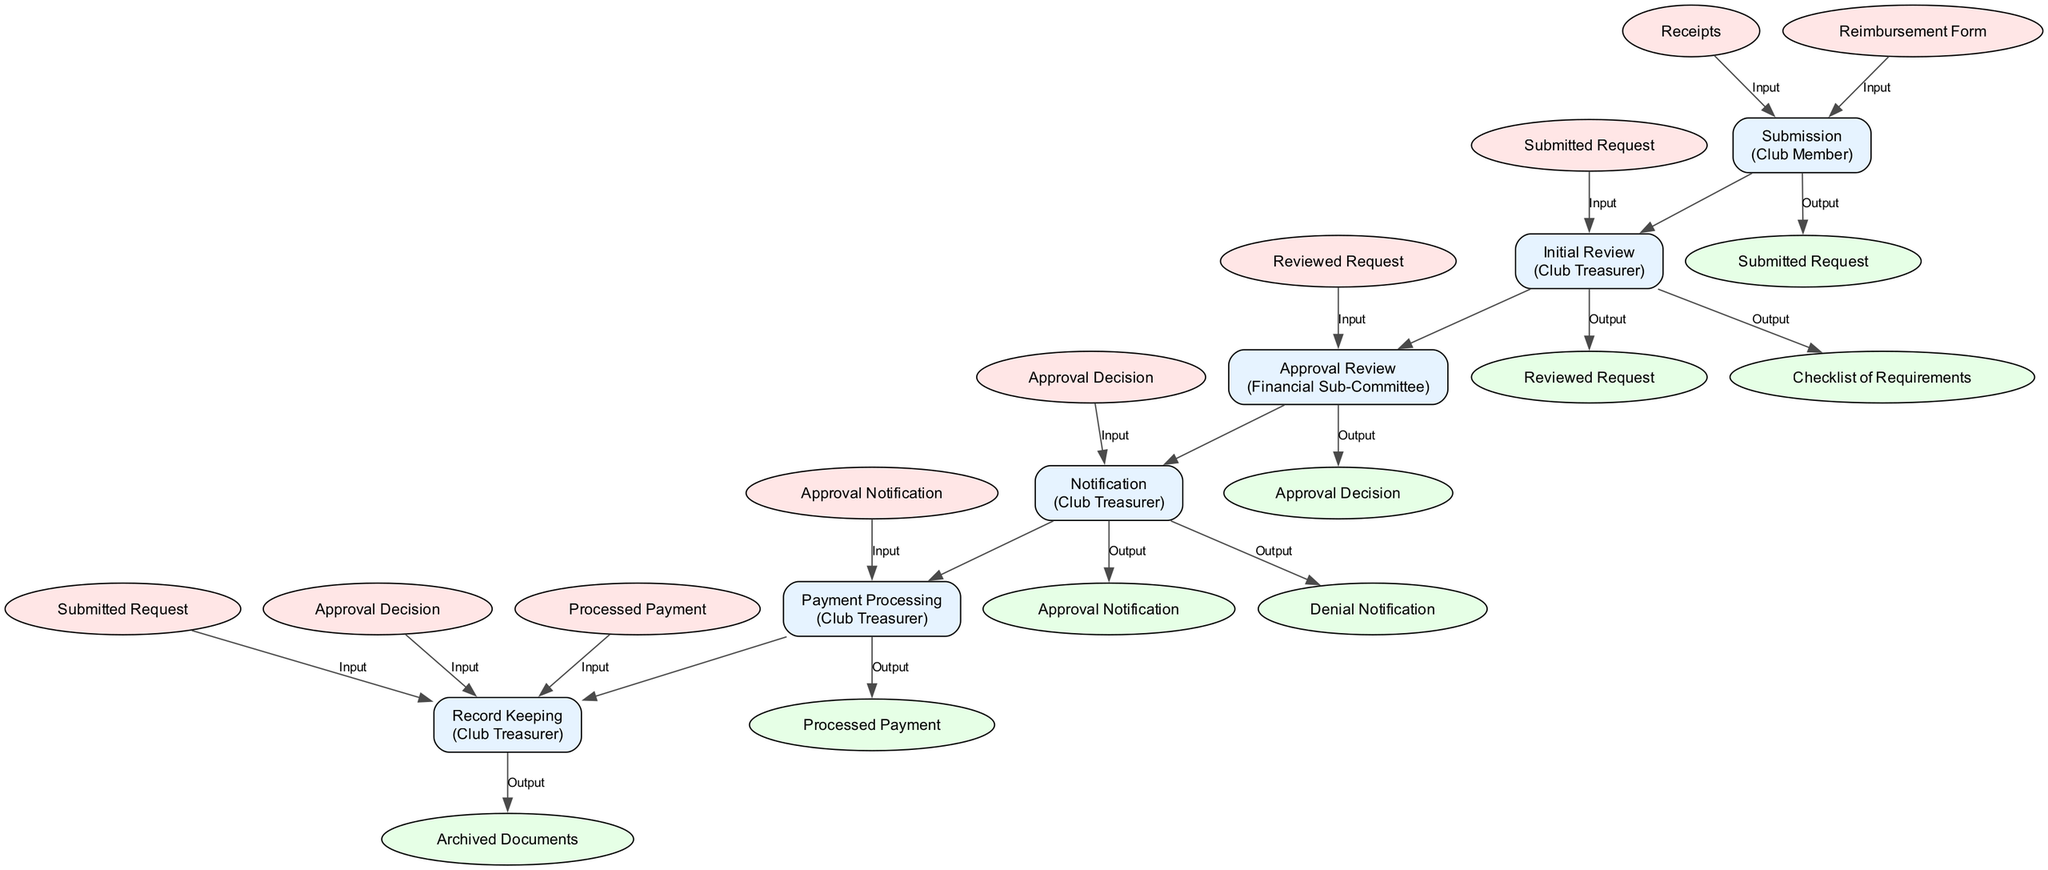What is the first step in the reimbursement procedure? The first step in the reimbursement procedure is "Submission" as indicated in the diagram.
Answer: Submission Who is responsible for the "Initial Review"? According to the diagram, the "Initial Review" is conducted by the "Club Treasurer".
Answer: Club Treasurer How many outputs does the "Approval Review" step generate? The "Approval Review" step generates one output, which is the "Approval Decision."
Answer: 1 What comes after the "Notification" step? After the "Notification" step, the next step is "Payment Processing". This is inferred by following the flow from "Notification" in the diagram.
Answer: Payment Processing What are the inputs required for the "Payment Processing" step? The input required for the "Payment Processing" step is the "Approval Notification". This is directly stated in the inputs section of the "Payment Processing" step in the diagram.
Answer: Approval Notification What is the final output in the reimbursement procedure? The final output of the reimbursement procedure is "Archived Documents" which comes from the last step "Record Keeping."
Answer: Archived Documents How many steps are in the reimbursement procedure? There are six steps in total, as counted from the nodes in the diagram that represent different steps in the process.
Answer: 6 What does the "Club Treasurer" do in the "Notification" step? In the "Notification" step, the "Club Treasurer" is responsible for notifying the member by either approving or denying the request, as specified in the description of the step.
Answer: Notify the member What is the output of the "Initial Review"? The outputs of the "Initial Review" step include "Reviewed Request" and "Checklist of Requirements." This is stated in the outputs section for that step in the diagram.
Answer: Reviewed Request, Checklist of Requirements 